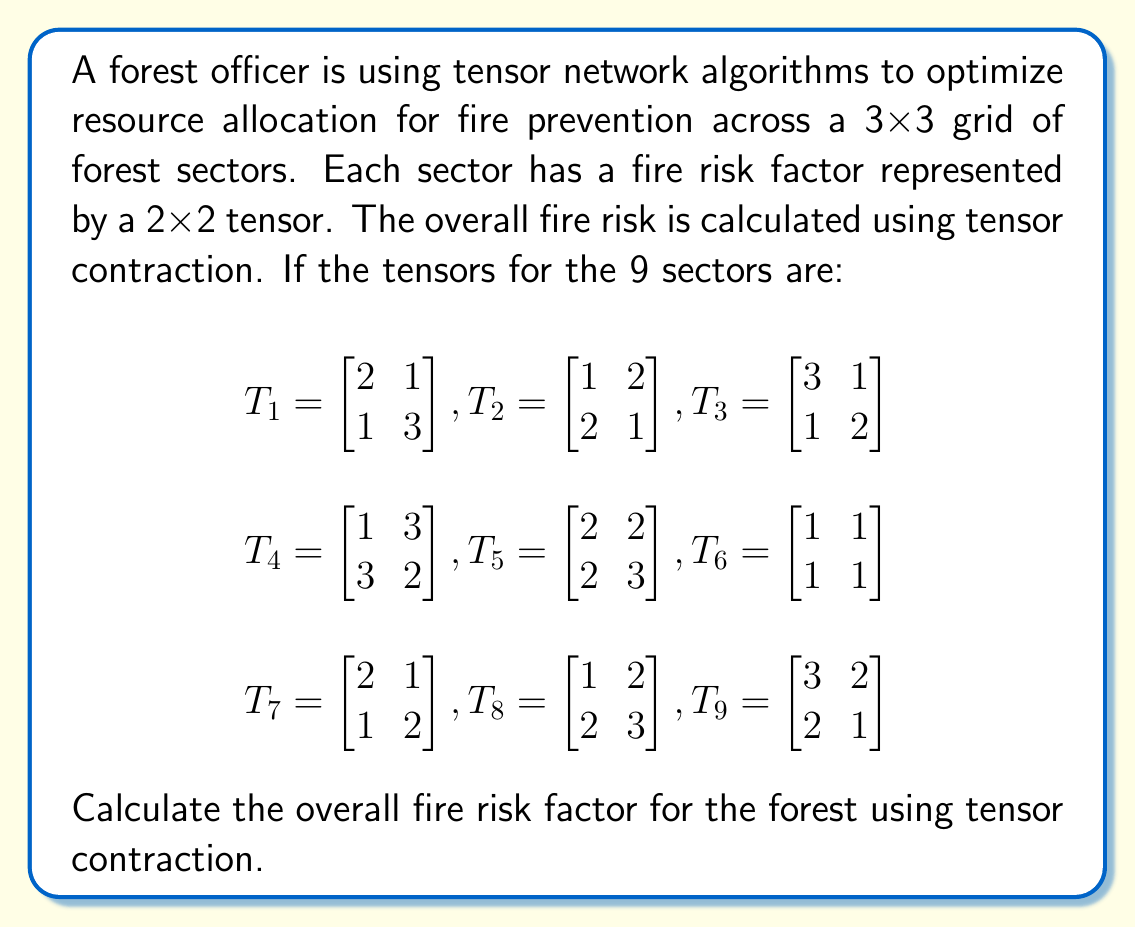Give your solution to this math problem. To solve this problem, we need to perform tensor contraction on the given 3x3 grid of 2x2 tensors. Here's a step-by-step approach:

1) First, we need to contract the tensors along each row:

   For row 1: $R_1 = T_1 \cdot T_2 \cdot T_3$
   For row 2: $R_2 = T_4 \cdot T_5 \cdot T_6$
   For row 3: $R_3 = T_7 \cdot T_8 \cdot T_9$

2) Let's calculate each row:

   $R_1 = \begin{bmatrix} 2 & 1 \\ 1 & 3 \end{bmatrix} \cdot 
          \begin{bmatrix} 1 & 2 \\ 2 & 1 \end{bmatrix} \cdot 
          \begin{bmatrix} 3 & 1 \\ 1 & 2 \end{bmatrix}$
   
   $R_1 = \begin{bmatrix} 4 & 5 \\ 7 & 5 \end{bmatrix} \cdot 
          \begin{bmatrix} 3 & 1 \\ 1 & 2 \end{bmatrix} = 
          \begin{bmatrix} 17 & 14 \\ 26 & 17 \end{bmatrix}$

   $R_2 = \begin{bmatrix} 1 & 3 \\ 3 & 2 \end{bmatrix} \cdot 
          \begin{bmatrix} 2 & 2 \\ 2 & 3 \end{bmatrix} \cdot 
          \begin{bmatrix} 1 & 1 \\ 1 & 1 \end{bmatrix}$
   
   $R_2 = \begin{bmatrix} 8 & 11 \\ 10 & 12 \end{bmatrix} \cdot 
          \begin{bmatrix} 1 & 1 \\ 1 & 1 \end{bmatrix} = 
          \begin{bmatrix} 19 & 19 \\ 22 & 22 \end{bmatrix}$

   $R_3 = \begin{bmatrix} 2 & 1 \\ 1 & 2 \end{bmatrix} \cdot 
          \begin{bmatrix} 1 & 2 \\ 2 & 3 \end{bmatrix} \cdot 
          \begin{bmatrix} 3 & 2 \\ 2 & 1 \end{bmatrix}$
   
   $R_3 = \begin{bmatrix} 4 & 7 \\ 5 & 8 \end{bmatrix} \cdot 
          \begin{bmatrix} 3 & 2 \\ 2 & 1 \end{bmatrix} = 
          \begin{bmatrix} 26 & 15 \\ 31 & 18 \end{bmatrix}$

3) Now we need to contract these results vertically:

   $R = R_1 \cdot R_2 \cdot R_3$

4) Calculating the final contraction:

   $R = \begin{bmatrix} 17 & 14 \\ 26 & 17 \end{bmatrix} \cdot 
        \begin{bmatrix} 19 & 19 \\ 22 & 22 \end{bmatrix} \cdot 
        \begin{bmatrix} 26 & 15 \\ 31 & 18 \end{bmatrix}$

   $R = \begin{bmatrix} 601 & 601 \\ 874 & 874 \end{bmatrix} \cdot 
        \begin{bmatrix} 26 & 15 \\ 31 & 18 \end{bmatrix}$

   $R = \begin{bmatrix} 34,217 & 19,833 \\ 49,706 & 28,812 \end{bmatrix}$

5) The overall fire risk factor is represented by this final 2x2 tensor.
Answer: $$\begin{bmatrix} 34,217 & 19,833 \\ 49,706 & 28,812 \end{bmatrix}$$ 